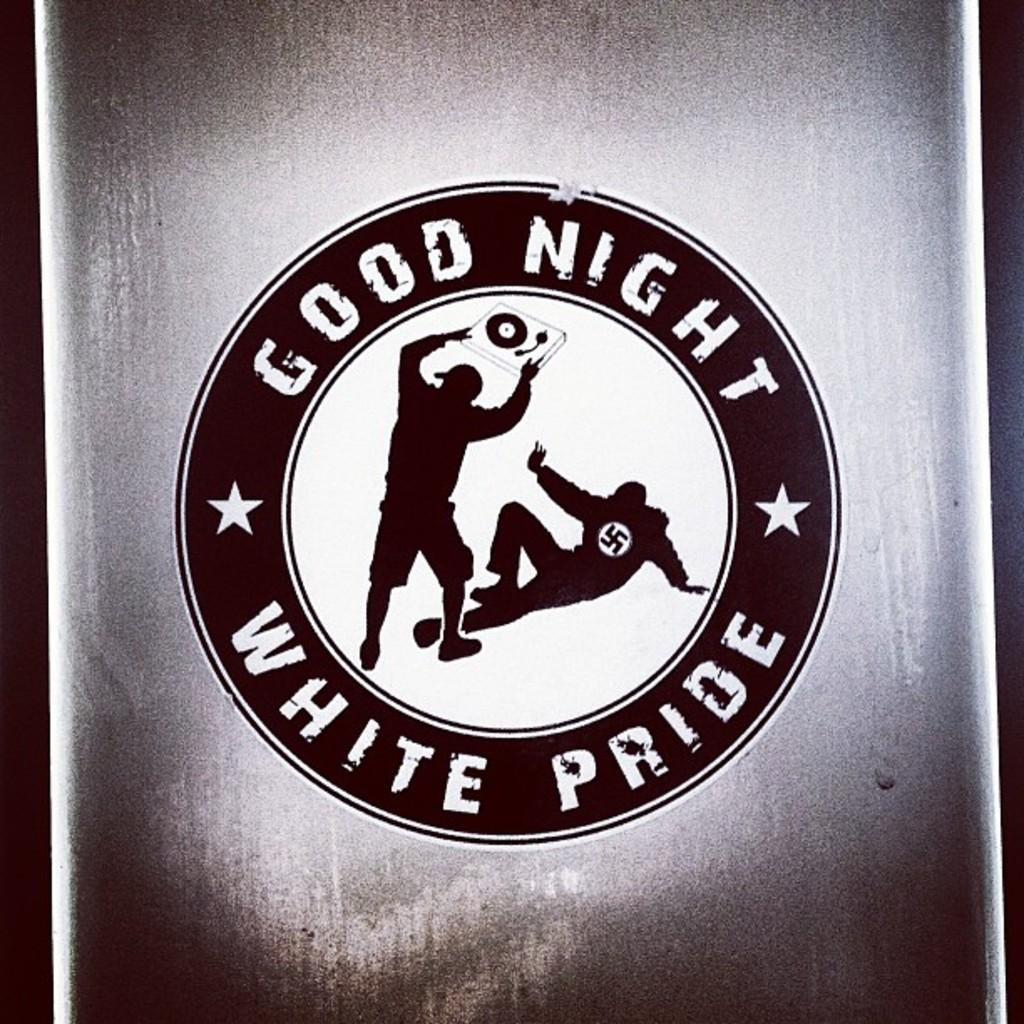Provide a one-sentence caption for the provided image. A black,while, and gray logo displaying a man on the ground with another man attacking him with the words Good Night White Pride around them. 